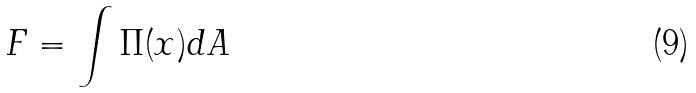Convert formula to latex. <formula><loc_0><loc_0><loc_500><loc_500>F = \int \Pi ( x ) d A</formula> 